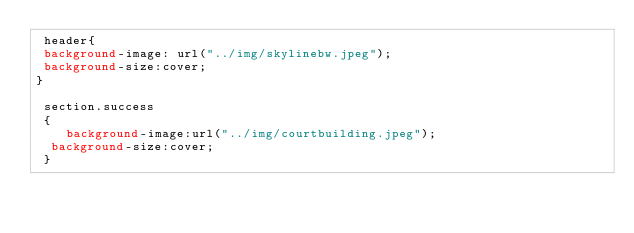Convert code to text. <code><loc_0><loc_0><loc_500><loc_500><_CSS_> header{
 background-image: url("../img/skylinebw.jpeg");
 background-size:cover;
}
 
 section.success
 {
    background-image:url("../img/courtbuilding.jpeg");
	background-size:cover;
 }
 </code> 